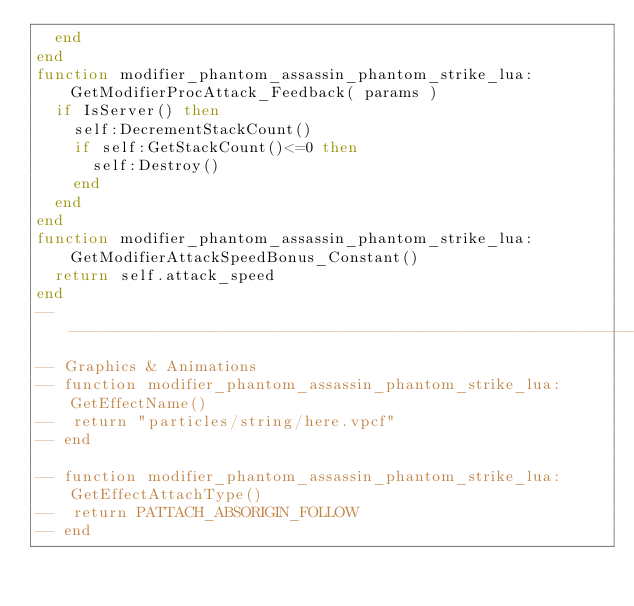Convert code to text. <code><loc_0><loc_0><loc_500><loc_500><_Lua_>	end
end
function modifier_phantom_assassin_phantom_strike_lua:GetModifierProcAttack_Feedback( params )
	if IsServer() then
		self:DecrementStackCount()
		if self:GetStackCount()<=0 then
			self:Destroy()
		end
	end
end
function modifier_phantom_assassin_phantom_strike_lua:GetModifierAttackSpeedBonus_Constant()
	return self.attack_speed
end
--------------------------------------------------------------------------------
-- Graphics & Animations
-- function modifier_phantom_assassin_phantom_strike_lua:GetEffectName()
-- 	return "particles/string/here.vpcf"
-- end

-- function modifier_phantom_assassin_phantom_strike_lua:GetEffectAttachType()
-- 	return PATTACH_ABSORIGIN_FOLLOW
-- end
</code> 